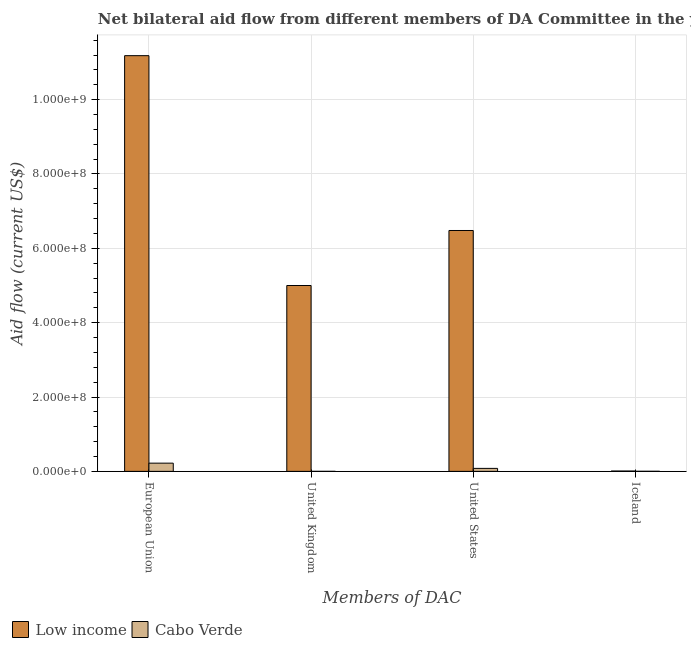How many different coloured bars are there?
Provide a short and direct response. 2. Are the number of bars on each tick of the X-axis equal?
Your answer should be very brief. Yes. How many bars are there on the 3rd tick from the left?
Your answer should be very brief. 2. What is the amount of aid given by eu in Cabo Verde?
Your answer should be compact. 2.21e+07. Across all countries, what is the maximum amount of aid given by iceland?
Your answer should be compact. 9.00e+05. Across all countries, what is the minimum amount of aid given by us?
Provide a succinct answer. 8.00e+06. In which country was the amount of aid given by uk maximum?
Ensure brevity in your answer.  Low income. In which country was the amount of aid given by iceland minimum?
Your answer should be compact. Cabo Verde. What is the total amount of aid given by us in the graph?
Offer a very short reply. 6.56e+08. What is the difference between the amount of aid given by us in Cabo Verde and that in Low income?
Give a very brief answer. -6.40e+08. What is the difference between the amount of aid given by iceland in Low income and the amount of aid given by us in Cabo Verde?
Your answer should be very brief. -7.10e+06. What is the average amount of aid given by eu per country?
Offer a very short reply. 5.70e+08. What is the difference between the amount of aid given by uk and amount of aid given by eu in Low income?
Your answer should be very brief. -6.18e+08. What is the ratio of the amount of aid given by uk in Cabo Verde to that in Low income?
Provide a short and direct response. 8e-5. Is the difference between the amount of aid given by uk in Low income and Cabo Verde greater than the difference between the amount of aid given by iceland in Low income and Cabo Verde?
Ensure brevity in your answer.  Yes. What is the difference between the highest and the second highest amount of aid given by iceland?
Your response must be concise. 6.80e+05. What is the difference between the highest and the lowest amount of aid given by us?
Keep it short and to the point. 6.40e+08. In how many countries, is the amount of aid given by us greater than the average amount of aid given by us taken over all countries?
Ensure brevity in your answer.  1. What does the 2nd bar from the left in United Kingdom represents?
Give a very brief answer. Cabo Verde. What does the 1st bar from the right in United States represents?
Make the answer very short. Cabo Verde. How many countries are there in the graph?
Your answer should be very brief. 2. What is the difference between two consecutive major ticks on the Y-axis?
Offer a terse response. 2.00e+08. Are the values on the major ticks of Y-axis written in scientific E-notation?
Your answer should be compact. Yes. Where does the legend appear in the graph?
Provide a succinct answer. Bottom left. How many legend labels are there?
Your answer should be very brief. 2. How are the legend labels stacked?
Your response must be concise. Horizontal. What is the title of the graph?
Keep it short and to the point. Net bilateral aid flow from different members of DA Committee in the year 1997. Does "Sweden" appear as one of the legend labels in the graph?
Your response must be concise. No. What is the label or title of the X-axis?
Offer a terse response. Members of DAC. What is the label or title of the Y-axis?
Ensure brevity in your answer.  Aid flow (current US$). What is the Aid flow (current US$) of Low income in European Union?
Make the answer very short. 1.12e+09. What is the Aid flow (current US$) of Cabo Verde in European Union?
Your response must be concise. 2.21e+07. What is the Aid flow (current US$) of Low income in United Kingdom?
Ensure brevity in your answer.  5.00e+08. What is the Aid flow (current US$) of Low income in United States?
Offer a terse response. 6.48e+08. What is the Aid flow (current US$) of Low income in Iceland?
Your response must be concise. 9.00e+05. What is the Aid flow (current US$) in Cabo Verde in Iceland?
Ensure brevity in your answer.  2.20e+05. Across all Members of DAC, what is the maximum Aid flow (current US$) in Low income?
Your response must be concise. 1.12e+09. Across all Members of DAC, what is the maximum Aid flow (current US$) of Cabo Verde?
Provide a short and direct response. 2.21e+07. What is the total Aid flow (current US$) of Low income in the graph?
Give a very brief answer. 2.27e+09. What is the total Aid flow (current US$) of Cabo Verde in the graph?
Offer a very short reply. 3.04e+07. What is the difference between the Aid flow (current US$) of Low income in European Union and that in United Kingdom?
Give a very brief answer. 6.18e+08. What is the difference between the Aid flow (current US$) of Cabo Verde in European Union and that in United Kingdom?
Your response must be concise. 2.20e+07. What is the difference between the Aid flow (current US$) of Low income in European Union and that in United States?
Provide a succinct answer. 4.70e+08. What is the difference between the Aid flow (current US$) in Cabo Verde in European Union and that in United States?
Offer a very short reply. 1.41e+07. What is the difference between the Aid flow (current US$) in Low income in European Union and that in Iceland?
Your answer should be compact. 1.12e+09. What is the difference between the Aid flow (current US$) of Cabo Verde in European Union and that in Iceland?
Ensure brevity in your answer.  2.19e+07. What is the difference between the Aid flow (current US$) in Low income in United Kingdom and that in United States?
Provide a short and direct response. -1.48e+08. What is the difference between the Aid flow (current US$) in Cabo Verde in United Kingdom and that in United States?
Give a very brief answer. -7.96e+06. What is the difference between the Aid flow (current US$) of Low income in United Kingdom and that in Iceland?
Give a very brief answer. 4.99e+08. What is the difference between the Aid flow (current US$) in Low income in United States and that in Iceland?
Provide a short and direct response. 6.47e+08. What is the difference between the Aid flow (current US$) of Cabo Verde in United States and that in Iceland?
Offer a very short reply. 7.78e+06. What is the difference between the Aid flow (current US$) of Low income in European Union and the Aid flow (current US$) of Cabo Verde in United Kingdom?
Your response must be concise. 1.12e+09. What is the difference between the Aid flow (current US$) in Low income in European Union and the Aid flow (current US$) in Cabo Verde in United States?
Your answer should be very brief. 1.11e+09. What is the difference between the Aid flow (current US$) of Low income in European Union and the Aid flow (current US$) of Cabo Verde in Iceland?
Keep it short and to the point. 1.12e+09. What is the difference between the Aid flow (current US$) of Low income in United Kingdom and the Aid flow (current US$) of Cabo Verde in United States?
Provide a short and direct response. 4.92e+08. What is the difference between the Aid flow (current US$) of Low income in United Kingdom and the Aid flow (current US$) of Cabo Verde in Iceland?
Make the answer very short. 5.00e+08. What is the difference between the Aid flow (current US$) in Low income in United States and the Aid flow (current US$) in Cabo Verde in Iceland?
Offer a terse response. 6.48e+08. What is the average Aid flow (current US$) of Low income per Members of DAC?
Offer a terse response. 5.67e+08. What is the average Aid flow (current US$) of Cabo Verde per Members of DAC?
Your response must be concise. 7.59e+06. What is the difference between the Aid flow (current US$) in Low income and Aid flow (current US$) in Cabo Verde in European Union?
Make the answer very short. 1.10e+09. What is the difference between the Aid flow (current US$) of Low income and Aid flow (current US$) of Cabo Verde in United Kingdom?
Keep it short and to the point. 5.00e+08. What is the difference between the Aid flow (current US$) in Low income and Aid flow (current US$) in Cabo Verde in United States?
Your answer should be very brief. 6.40e+08. What is the difference between the Aid flow (current US$) in Low income and Aid flow (current US$) in Cabo Verde in Iceland?
Ensure brevity in your answer.  6.80e+05. What is the ratio of the Aid flow (current US$) in Low income in European Union to that in United Kingdom?
Offer a terse response. 2.24. What is the ratio of the Aid flow (current US$) in Cabo Verde in European Union to that in United Kingdom?
Offer a very short reply. 552.25. What is the ratio of the Aid flow (current US$) in Low income in European Union to that in United States?
Provide a short and direct response. 1.73. What is the ratio of the Aid flow (current US$) in Cabo Verde in European Union to that in United States?
Provide a succinct answer. 2.76. What is the ratio of the Aid flow (current US$) of Low income in European Union to that in Iceland?
Your answer should be compact. 1242.63. What is the ratio of the Aid flow (current US$) of Cabo Verde in European Union to that in Iceland?
Your response must be concise. 100.41. What is the ratio of the Aid flow (current US$) of Low income in United Kingdom to that in United States?
Offer a terse response. 0.77. What is the ratio of the Aid flow (current US$) in Cabo Verde in United Kingdom to that in United States?
Your answer should be compact. 0.01. What is the ratio of the Aid flow (current US$) of Low income in United Kingdom to that in Iceland?
Make the answer very short. 555.56. What is the ratio of the Aid flow (current US$) in Cabo Verde in United Kingdom to that in Iceland?
Your response must be concise. 0.18. What is the ratio of the Aid flow (current US$) in Low income in United States to that in Iceland?
Your answer should be compact. 720. What is the ratio of the Aid flow (current US$) of Cabo Verde in United States to that in Iceland?
Give a very brief answer. 36.36. What is the difference between the highest and the second highest Aid flow (current US$) of Low income?
Offer a terse response. 4.70e+08. What is the difference between the highest and the second highest Aid flow (current US$) in Cabo Verde?
Give a very brief answer. 1.41e+07. What is the difference between the highest and the lowest Aid flow (current US$) in Low income?
Keep it short and to the point. 1.12e+09. What is the difference between the highest and the lowest Aid flow (current US$) of Cabo Verde?
Your response must be concise. 2.20e+07. 